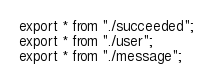Convert code to text. <code><loc_0><loc_0><loc_500><loc_500><_TypeScript_>export * from "./succeeded";
export * from "./user";
export * from "./message";
</code> 